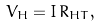Convert formula to latex. <formula><loc_0><loc_0><loc_500><loc_500>V _ { H } = I \, R _ { H T } ,</formula> 